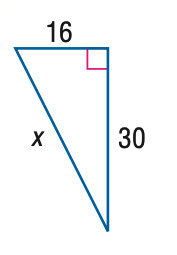Question: Use a Pythagorean Triple to find x.
Choices:
A. 32
B. 34
C. 36
D. 38
Answer with the letter. Answer: B 